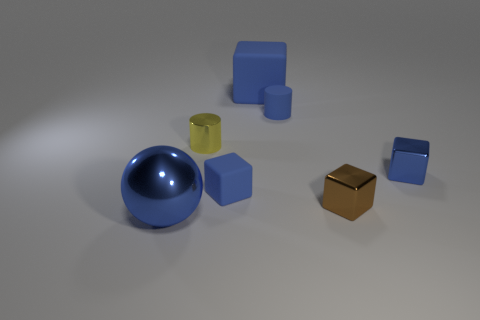How many blue blocks must be subtracted to get 1 blue blocks? 2 Subtract all tiny rubber cubes. How many cubes are left? 3 Subtract all red balls. How many blue cubes are left? 3 Subtract all brown blocks. How many blocks are left? 3 Subtract all cyan blocks. Subtract all cyan balls. How many blocks are left? 4 Add 2 tiny metallic cylinders. How many objects exist? 9 Subtract all balls. How many objects are left? 6 Add 5 blue matte cylinders. How many blue matte cylinders are left? 6 Add 4 large gray shiny spheres. How many large gray shiny spheres exist? 4 Subtract 0 purple spheres. How many objects are left? 7 